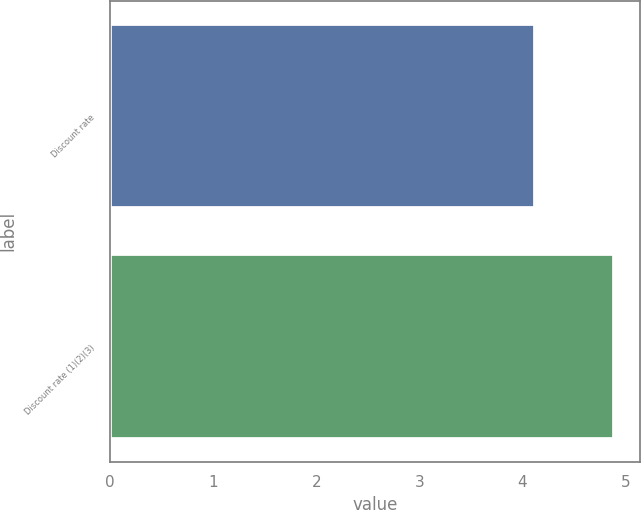Convert chart to OTSL. <chart><loc_0><loc_0><loc_500><loc_500><bar_chart><fcel>Discount rate<fcel>Discount rate (1)(2)(3)<nl><fcel>4.12<fcel>4.89<nl></chart> 